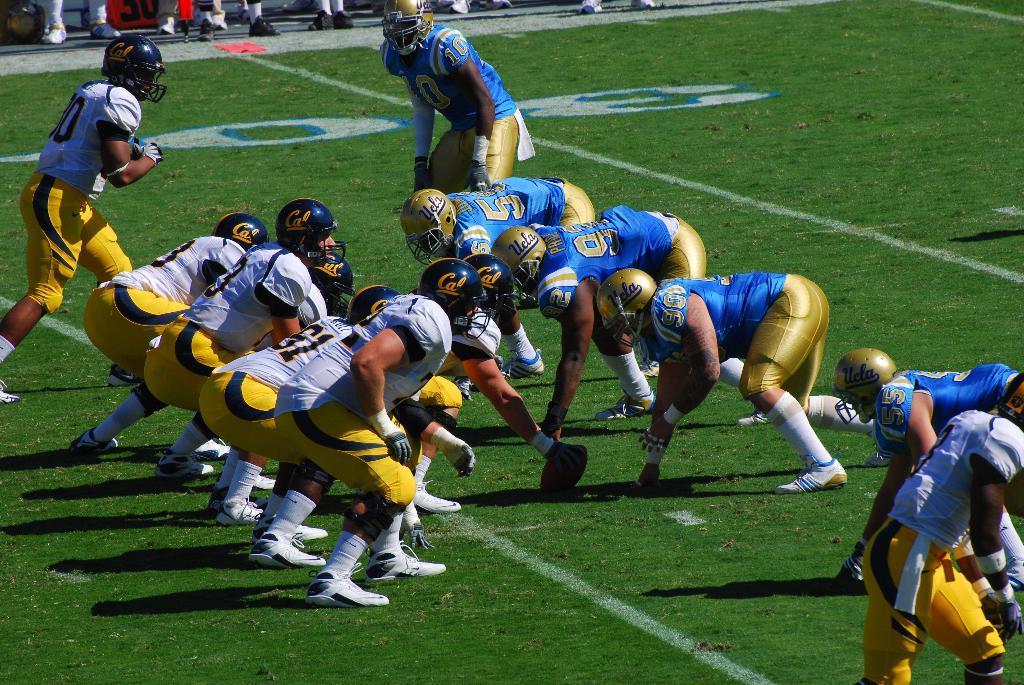Could you give a brief overview of what you see in this image? In this image at the center people are playing sport. At the back side few people are standing on the ground. 